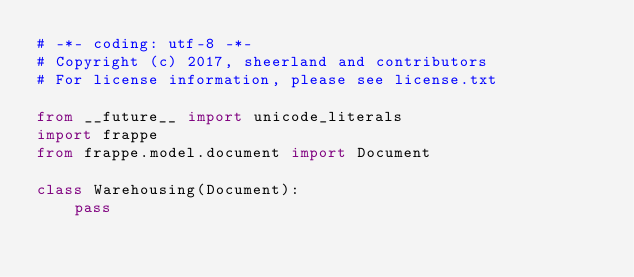Convert code to text. <code><loc_0><loc_0><loc_500><loc_500><_Python_># -*- coding: utf-8 -*-
# Copyright (c) 2017, sheerland and contributors
# For license information, please see license.txt

from __future__ import unicode_literals
import frappe
from frappe.model.document import Document

class Warehousing(Document):
	pass
</code> 